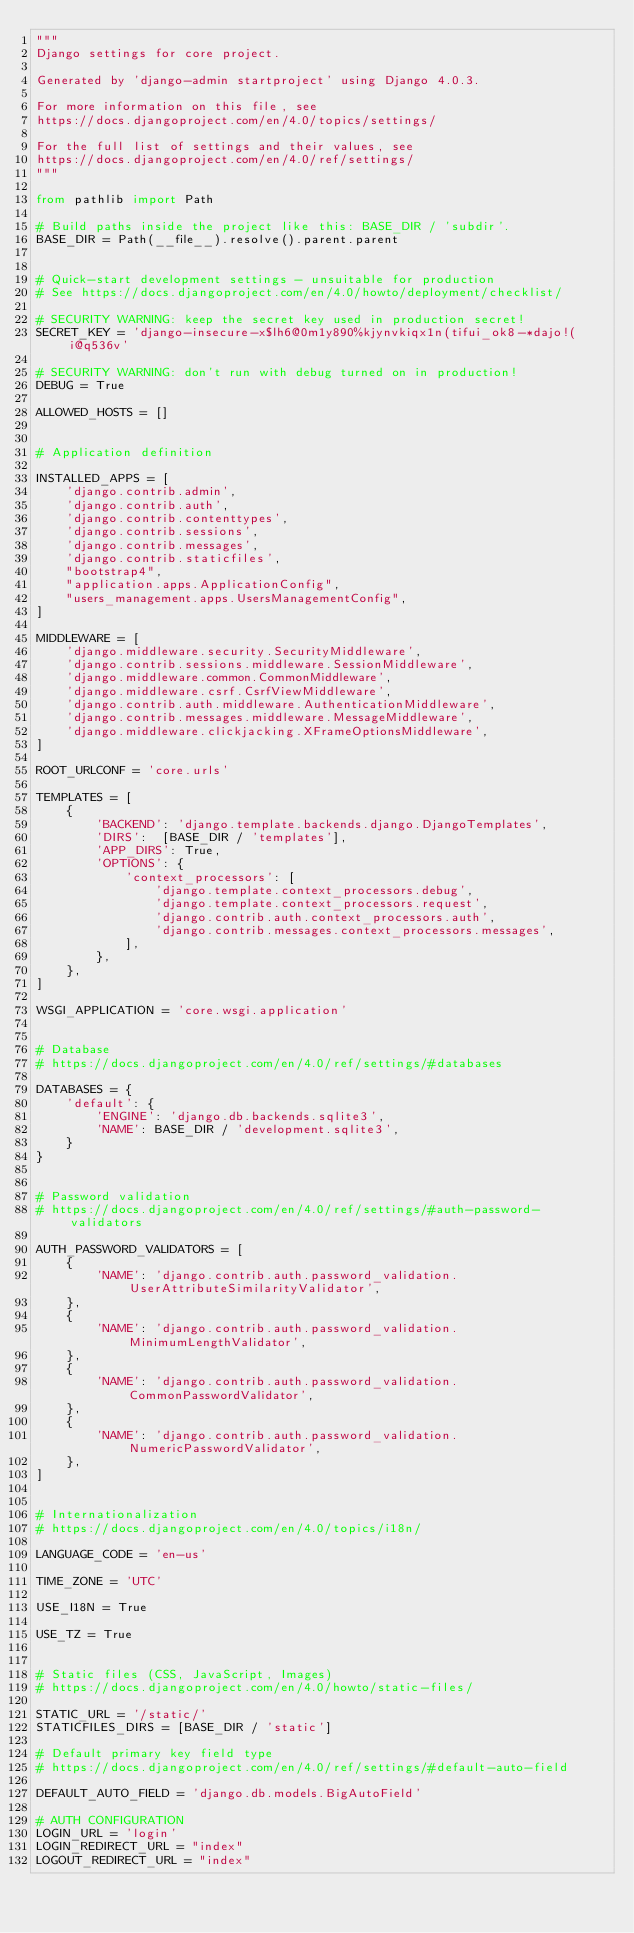Convert code to text. <code><loc_0><loc_0><loc_500><loc_500><_Python_>"""
Django settings for core project.

Generated by 'django-admin startproject' using Django 4.0.3.

For more information on this file, see
https://docs.djangoproject.com/en/4.0/topics/settings/

For the full list of settings and their values, see
https://docs.djangoproject.com/en/4.0/ref/settings/
"""

from pathlib import Path

# Build paths inside the project like this: BASE_DIR / 'subdir'.
BASE_DIR = Path(__file__).resolve().parent.parent


# Quick-start development settings - unsuitable for production
# See https://docs.djangoproject.com/en/4.0/howto/deployment/checklist/

# SECURITY WARNING: keep the secret key used in production secret!
SECRET_KEY = 'django-insecure-x$lh6@0m1y890%kjynvkiqx1n(tifui_ok8-*dajo!(i@q536v'

# SECURITY WARNING: don't run with debug turned on in production!
DEBUG = True

ALLOWED_HOSTS = []


# Application definition

INSTALLED_APPS = [
    'django.contrib.admin',
    'django.contrib.auth',
    'django.contrib.contenttypes',
    'django.contrib.sessions',
    'django.contrib.messages',
    'django.contrib.staticfiles',
    "bootstrap4",
    "application.apps.ApplicationConfig",
    "users_management.apps.UsersManagementConfig",
]

MIDDLEWARE = [
    'django.middleware.security.SecurityMiddleware',
    'django.contrib.sessions.middleware.SessionMiddleware',
    'django.middleware.common.CommonMiddleware',
    'django.middleware.csrf.CsrfViewMiddleware',
    'django.contrib.auth.middleware.AuthenticationMiddleware',
    'django.contrib.messages.middleware.MessageMiddleware',
    'django.middleware.clickjacking.XFrameOptionsMiddleware',
]

ROOT_URLCONF = 'core.urls'

TEMPLATES = [
    {
        'BACKEND': 'django.template.backends.django.DjangoTemplates',
        'DIRS':  [BASE_DIR / 'templates'],
        'APP_DIRS': True,
        'OPTIONS': {
            'context_processors': [
                'django.template.context_processors.debug',
                'django.template.context_processors.request',
                'django.contrib.auth.context_processors.auth',
                'django.contrib.messages.context_processors.messages',
            ],
        },
    },
]

WSGI_APPLICATION = 'core.wsgi.application'


# Database
# https://docs.djangoproject.com/en/4.0/ref/settings/#databases

DATABASES = {
    'default': {
        'ENGINE': 'django.db.backends.sqlite3',
        'NAME': BASE_DIR / 'development.sqlite3',
    }
}


# Password validation
# https://docs.djangoproject.com/en/4.0/ref/settings/#auth-password-validators

AUTH_PASSWORD_VALIDATORS = [
    {
        'NAME': 'django.contrib.auth.password_validation.UserAttributeSimilarityValidator',
    },
    {
        'NAME': 'django.contrib.auth.password_validation.MinimumLengthValidator',
    },
    {
        'NAME': 'django.contrib.auth.password_validation.CommonPasswordValidator',
    },
    {
        'NAME': 'django.contrib.auth.password_validation.NumericPasswordValidator',
    },
]


# Internationalization
# https://docs.djangoproject.com/en/4.0/topics/i18n/

LANGUAGE_CODE = 'en-us'

TIME_ZONE = 'UTC'

USE_I18N = True

USE_TZ = True


# Static files (CSS, JavaScript, Images)
# https://docs.djangoproject.com/en/4.0/howto/static-files/

STATIC_URL = '/static/'
STATICFILES_DIRS = [BASE_DIR / 'static']

# Default primary key field type
# https://docs.djangoproject.com/en/4.0/ref/settings/#default-auto-field

DEFAULT_AUTO_FIELD = 'django.db.models.BigAutoField'

# AUTH CONFIGURATION
LOGIN_URL = 'login'
LOGIN_REDIRECT_URL = "index"
LOGOUT_REDIRECT_URL = "index"
</code> 